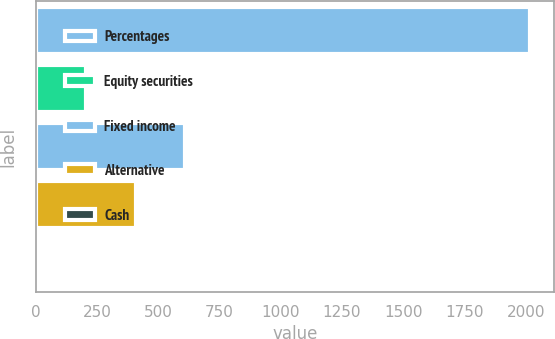Convert chart to OTSL. <chart><loc_0><loc_0><loc_500><loc_500><bar_chart><fcel>Percentages<fcel>Equity securities<fcel>Fixed income<fcel>Alternative<fcel>Cash<nl><fcel>2016<fcel>206.1<fcel>608.3<fcel>407.2<fcel>5<nl></chart> 